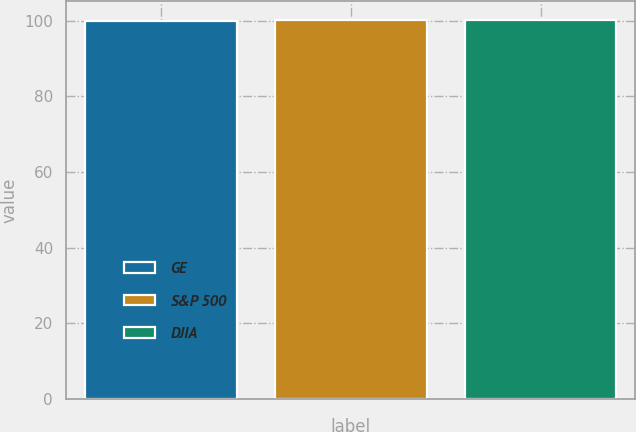Convert chart to OTSL. <chart><loc_0><loc_0><loc_500><loc_500><bar_chart><fcel>GE<fcel>S&P 500<fcel>DJIA<nl><fcel>100<fcel>100.1<fcel>100.2<nl></chart> 